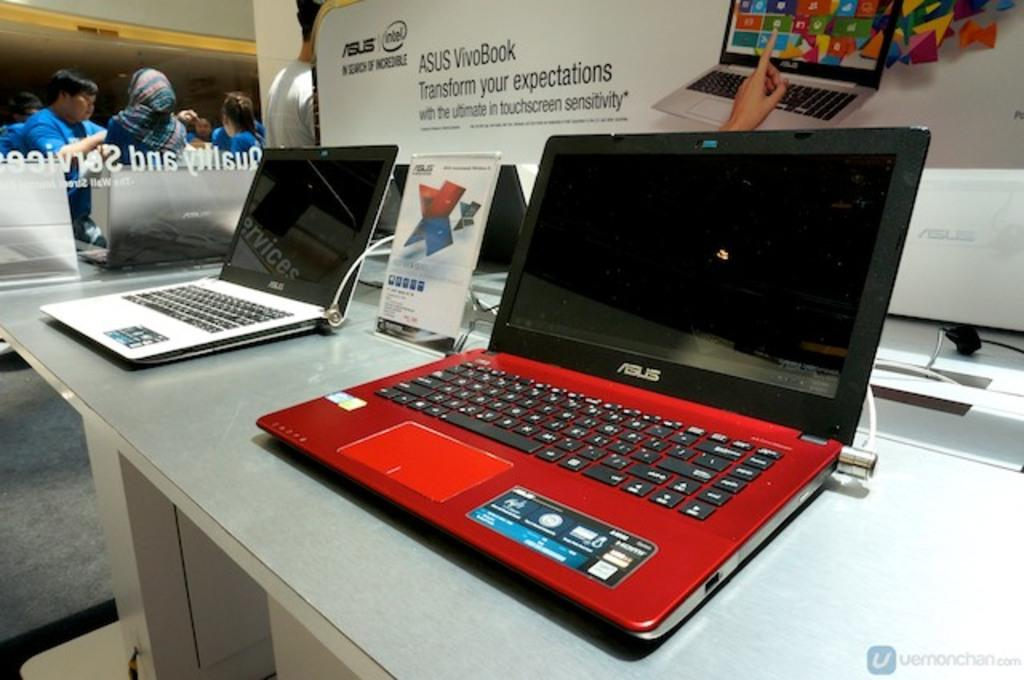Provide a one-sentence caption for the provided image. Red and black Asus laptop on display next to a silver laptop. 